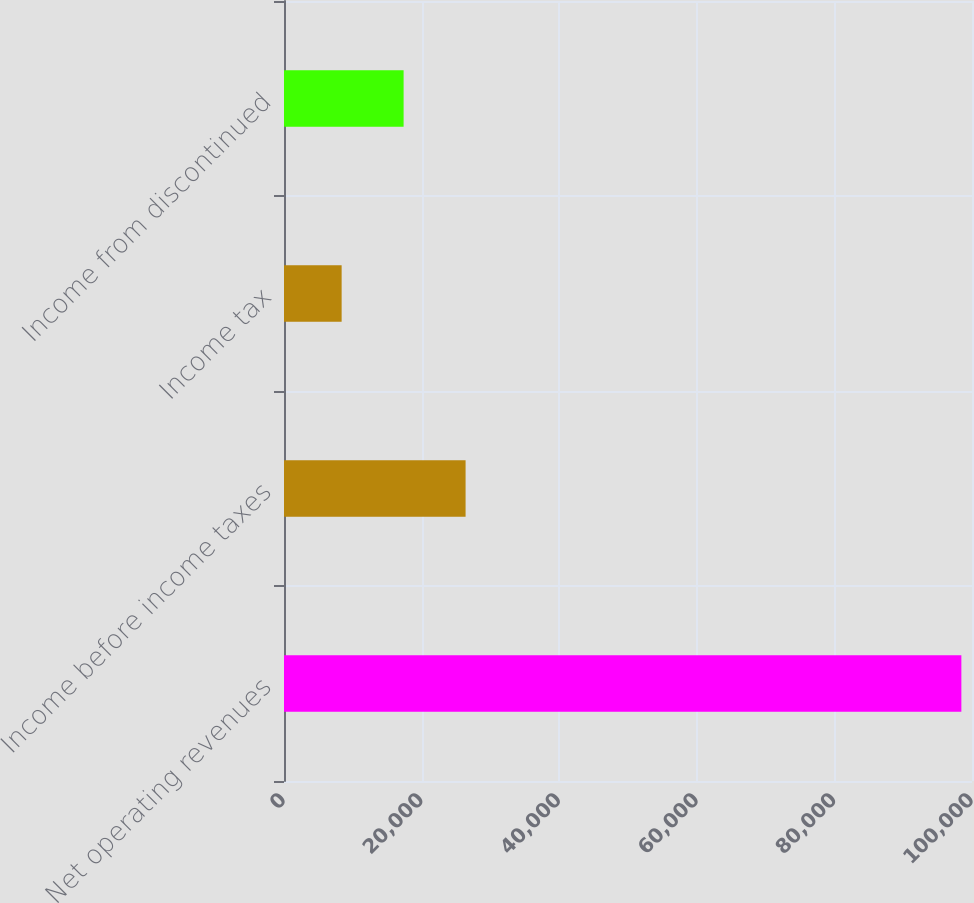Convert chart. <chart><loc_0><loc_0><loc_500><loc_500><bar_chart><fcel>Net operating revenues<fcel>Income before income taxes<fcel>Income tax<fcel>Income from discontinued<nl><fcel>98454<fcel>26392.4<fcel>8377<fcel>17384.7<nl></chart> 